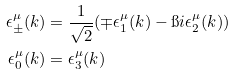<formula> <loc_0><loc_0><loc_500><loc_500>\epsilon ^ { \mu } _ { \pm } ( k ) & = \frac { 1 } { \sqrt { 2 } } ( \mp \epsilon ^ { \mu } _ { 1 } ( k ) - \i i \epsilon ^ { \mu } _ { 2 } ( k ) ) \\ \epsilon ^ { \mu } _ { 0 } ( k ) & = \epsilon ^ { \mu } _ { 3 } ( k )</formula> 